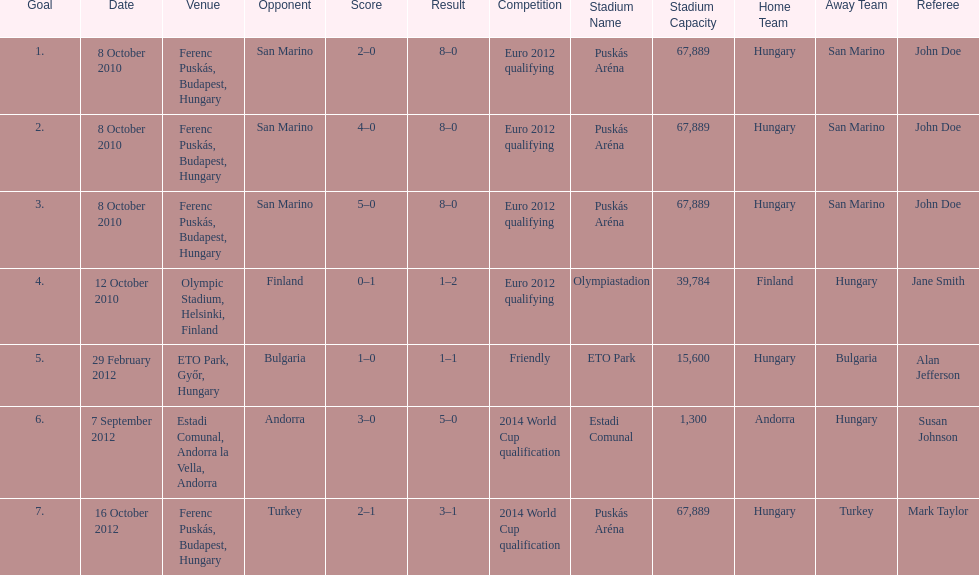How many non-qualifying games did he score in? 1. 